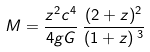Convert formula to latex. <formula><loc_0><loc_0><loc_500><loc_500>M = \frac { z ^ { 2 } c ^ { 4 } } { 4 g G } \, \frac { ( 2 + z ) ^ { 2 } } { ( 1 + z ) \, ^ { 3 } }</formula> 